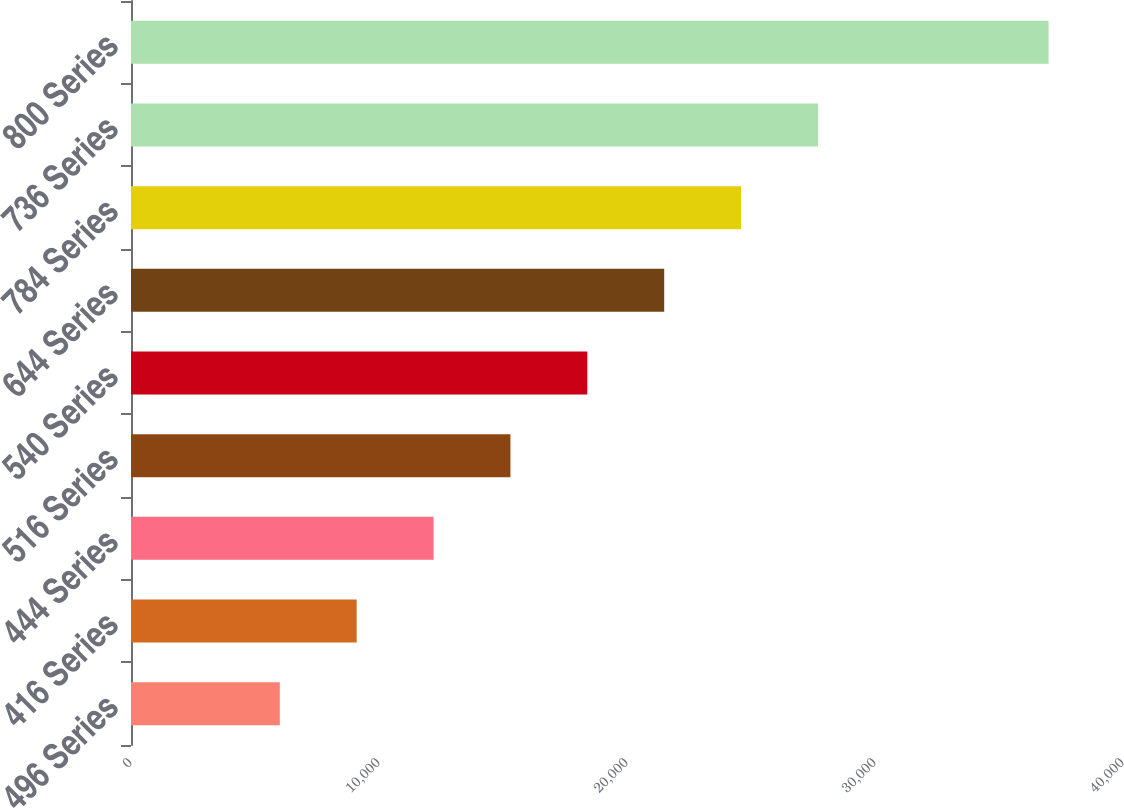<chart> <loc_0><loc_0><loc_500><loc_500><bar_chart><fcel>496 Series<fcel>416 Series<fcel>444 Series<fcel>516 Series<fcel>540 Series<fcel>644 Series<fcel>784 Series<fcel>736 Series<fcel>800 Series<nl><fcel>6000<fcel>9100<fcel>12200<fcel>15300<fcel>18400<fcel>21500<fcel>24600<fcel>27700<fcel>37000<nl></chart> 